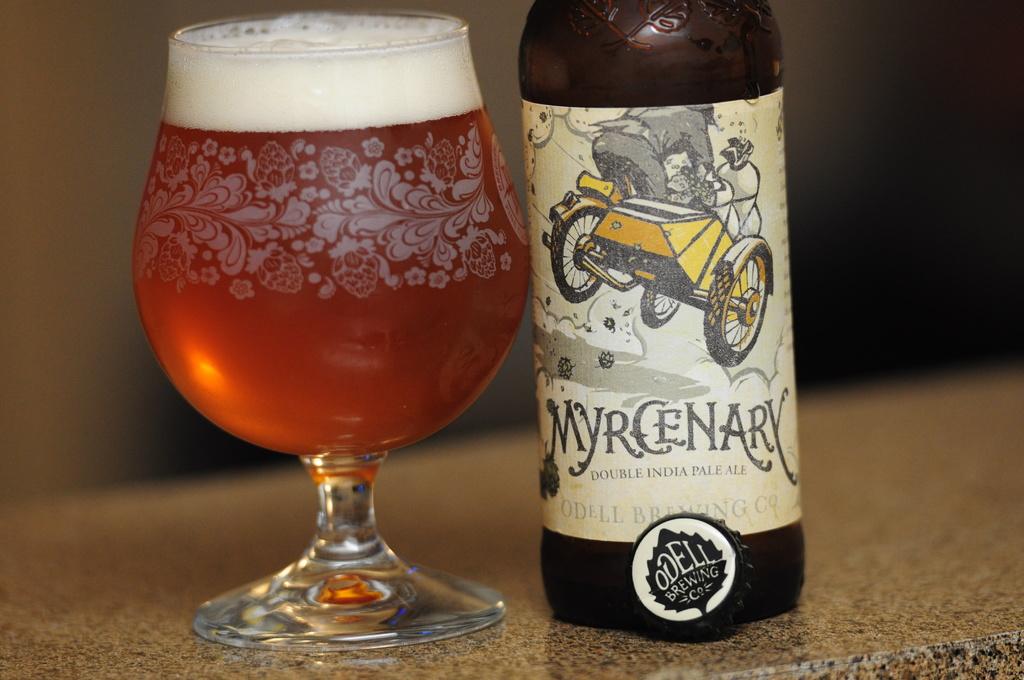What type of ale is in the bottle?
Your answer should be very brief. Double india pale ale. 